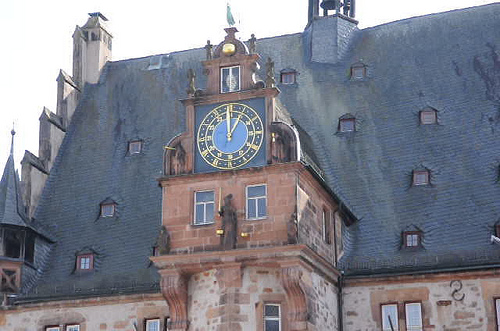What architectural style is represented in this building? The building features characteristics of traditional European architecture, likely from the Renaissance period, which is evident from the symmetry, proportion, and the use of classical elements such as the clock with roman numerals and the ornate decoration. 